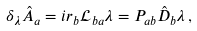<formula> <loc_0><loc_0><loc_500><loc_500>\delta _ { \lambda } \hat { A } _ { a } & = i r _ { b } \mathcal { L } _ { b a } \lambda = P _ { a b } \hat { D } _ { b } \lambda \, ,</formula> 